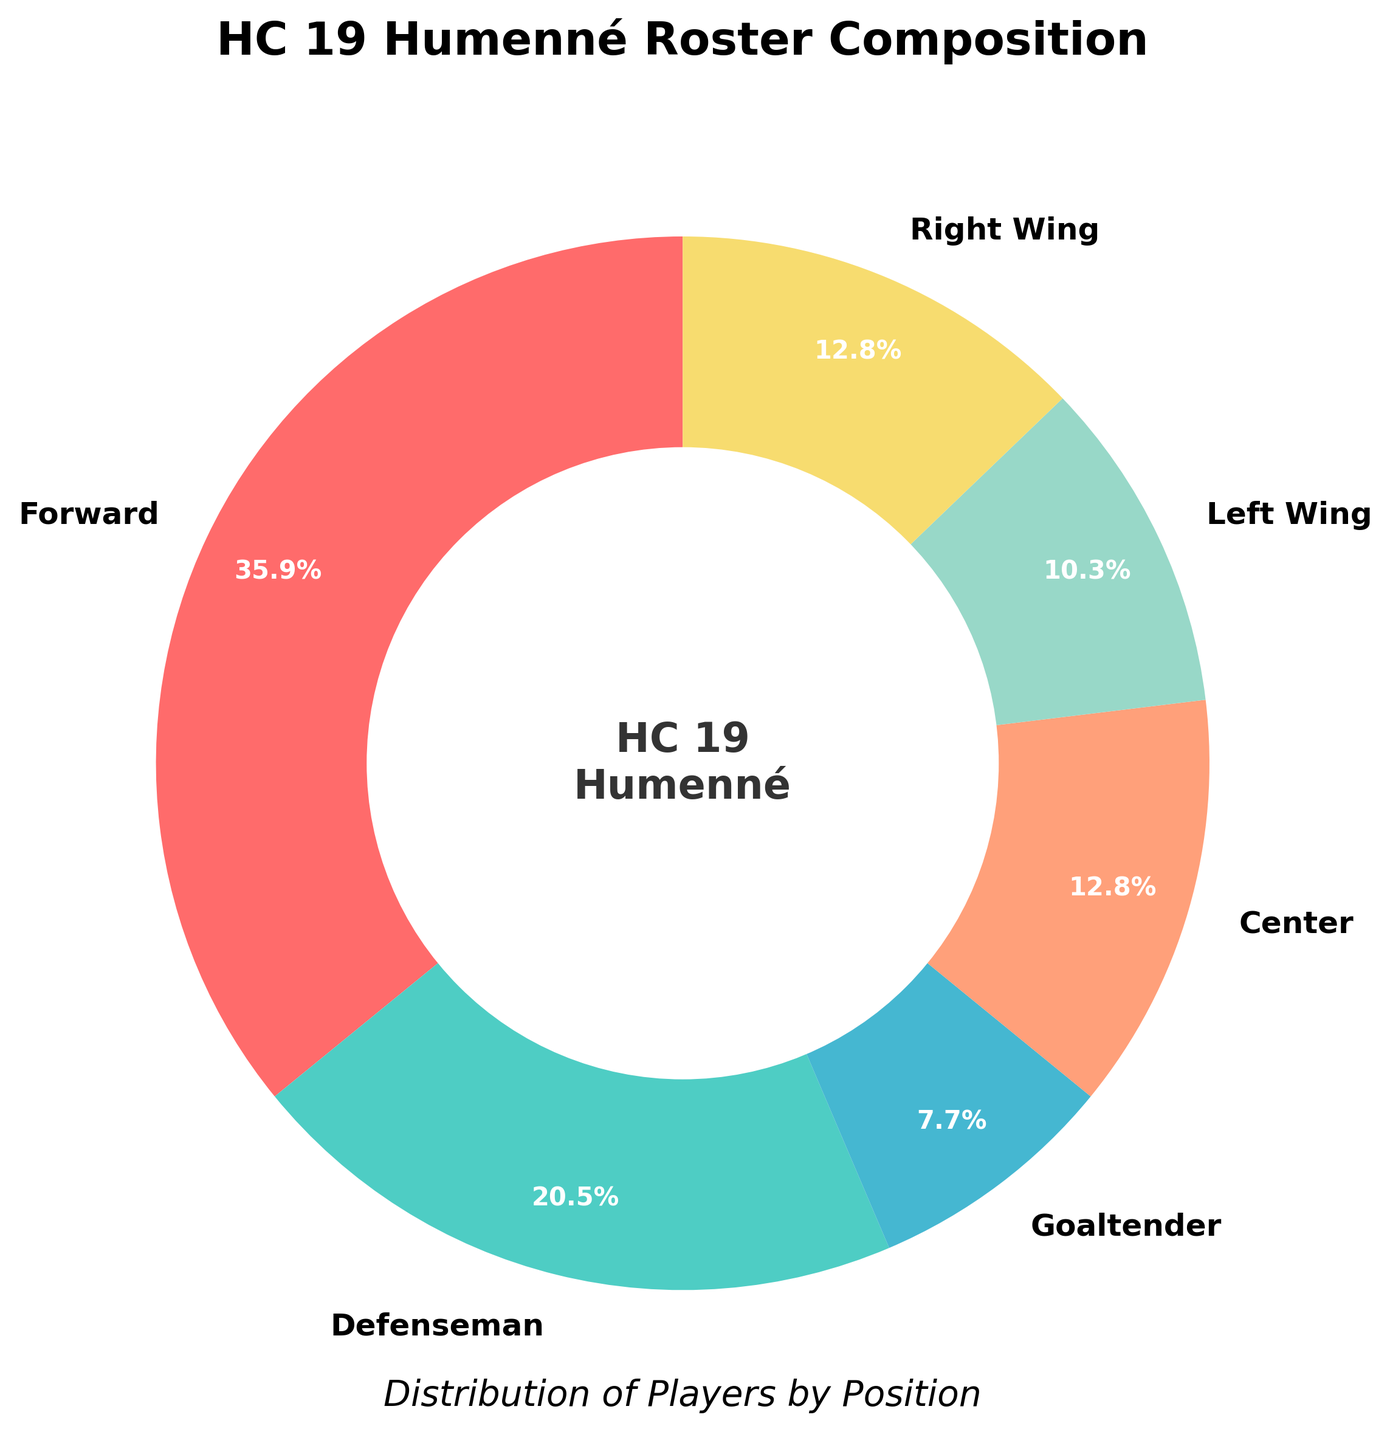What percentage of HC 19 Humenné's roster are goaltenders? To find the percentage of goaltenders, look at the slice labeled "Goaltender" in the pie chart which shows 3 players. The total number of players is the sum of all slices: 14 + 8 + 3 + 5 + 4 + 5 = 39. So, the percentage is (3/39) * 100 = 7.7%.
Answer: 7.7% Which position has the highest representation on the team? Look at the largest slice in the pie chart. The "Forward" position has the most significant portion, with 14 players.
Answer: Forward How many more defensemen are there compared to goaltenders? Check the slices of "Defenseman" and "Goaltender" in the pie chart. The "Defenseman" slice has 8 players, and the "Goaltender" slice has 3 players. Therefore, the difference is 8 - 3 = 5.
Answer: 5 What is the combined percentage of Centers and Right Wings? Look at the slices for "Center" and "Right Wing." Each slice has 5 players. First, add the players: 5 + 5 = 10. The total number of players is 39, so the combined percentage is (10/39) * 100 = 25.6%.
Answer: 25.6% Are there more Left Wings or Goaltenders? By how many? Compare the slices for "Left Wing" and "Goaltender." "Left Wing" has 4 players, and "Goaltender" has 3 players. The difference is 4 - 3 = 1.
Answer: Left Wings by 1 What position comprises approximately one-fifth of the roster? One-fifth of the roster is 20% of the total. Check the slices to see which one is closest to 20%. The "Defenseman" slice represents about 20.5% [(8/39) * 100 = 20.5%].
Answer: Defenseman What is the total number of forwards on the team, including specific wings (Left Wing, Right Wing)? Add the number of players in the "Forward," "Left Wing," and "Right Wing" slices: 14 (Forwards) + 4 (Left Wing) + 5 (Right Wing) = 23.
Answer: 23 Which two positions collectively make up more than half of the roster? Check each pair of sections to find a sum greater than 50%. "Forward" (14) and "Centers" (5) together make up 19 players. Similarly, "Forward" (14) and "Defenseman" (8) make up 22 players. Both exceed half of the total roster (39/2 = 19.5).
Answer: Forward and Defenseman What percentage of the team are wingers (Left Wing and Right Wing combined)? Add the players in "Left Wing" and "Right Wing": 4 + 5 = 9. The total is 39, so the percentage is (9/39) * 100 = 23.1%.
Answer: 23.1% How many more players are there in total compared to forwards alone? Total players on the team are 39. Players labeled as "Forward" are 14. The difference is 39 - 14 = 25.
Answer: 25 